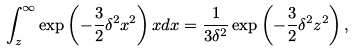<formula> <loc_0><loc_0><loc_500><loc_500>\int _ { z } ^ { \infty } \exp \left ( - \frac { 3 } { 2 } \delta ^ { 2 } x ^ { 2 } \right ) x d x = \frac { 1 } { 3 \delta ^ { 2 } } \exp \left ( - \frac { 3 } { 2 } \delta ^ { 2 } z ^ { 2 } \right ) ,</formula> 